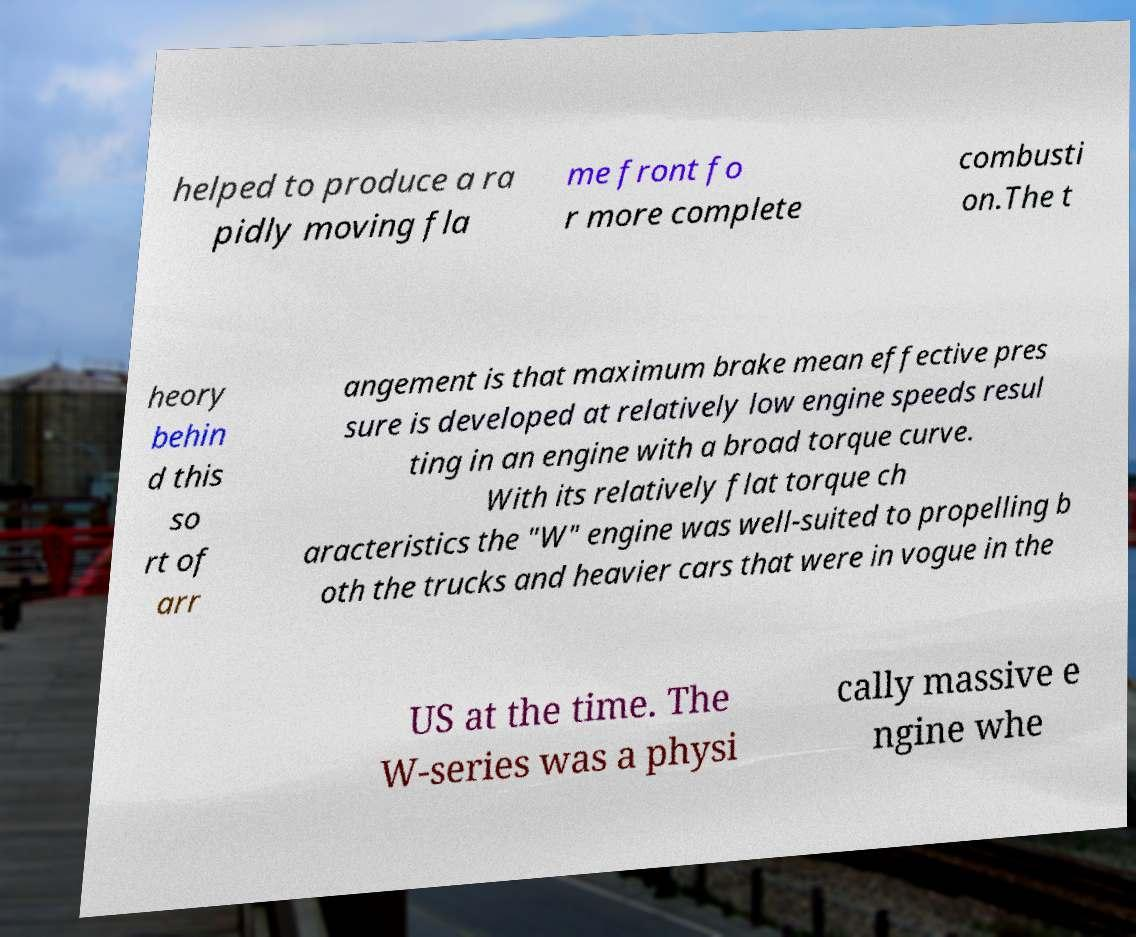Please identify and transcribe the text found in this image. helped to produce a ra pidly moving fla me front fo r more complete combusti on.The t heory behin d this so rt of arr angement is that maximum brake mean effective pres sure is developed at relatively low engine speeds resul ting in an engine with a broad torque curve. With its relatively flat torque ch aracteristics the "W" engine was well-suited to propelling b oth the trucks and heavier cars that were in vogue in the US at the time. The W-series was a physi cally massive e ngine whe 